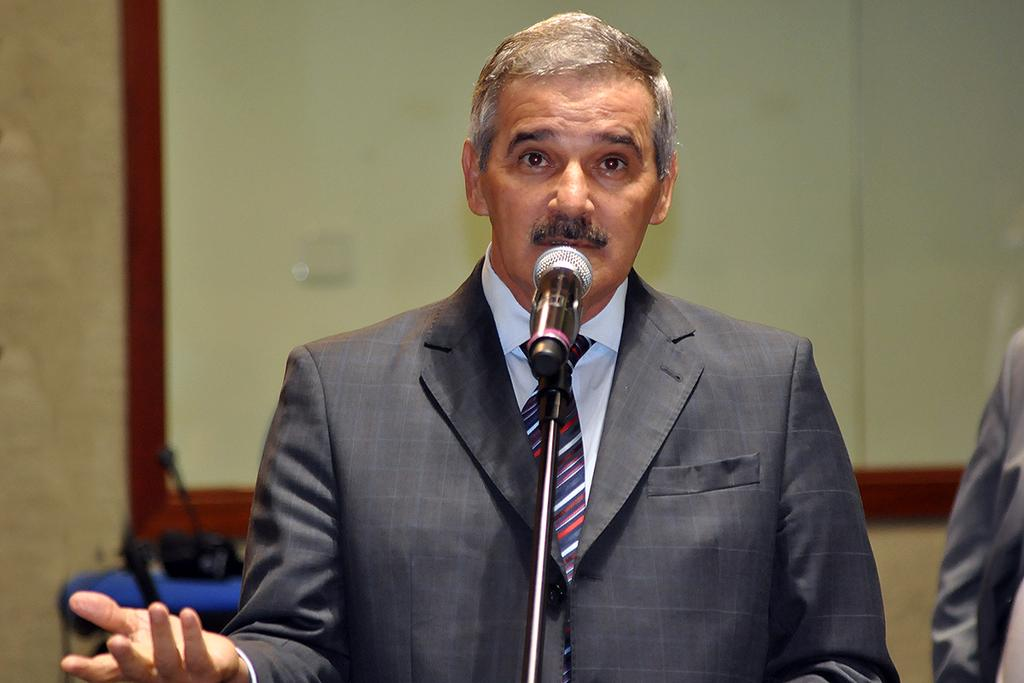What is the person in the image wearing? The person is wearing a coat and a tie. What is the person doing in the image? The person is standing in front of a microphone. How is the microphone positioned in the image? The microphone is placed on a stand. What can be seen in the background of the image? There is a board and another person in the background of the image. What type of lamp is illuminating the person in the image? There is no lamp present in the image; the person is standing in front of a microphone. What is the person holding in their hand in the image? The provided facts do not mention the person holding anything in their hand. 